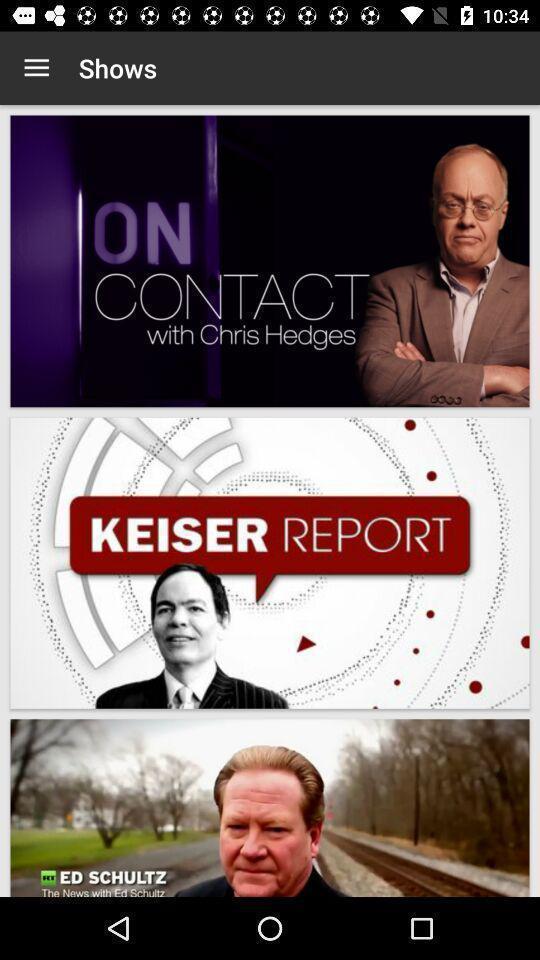Tell me about the visual elements in this screen capture. Page showing different shows s. 